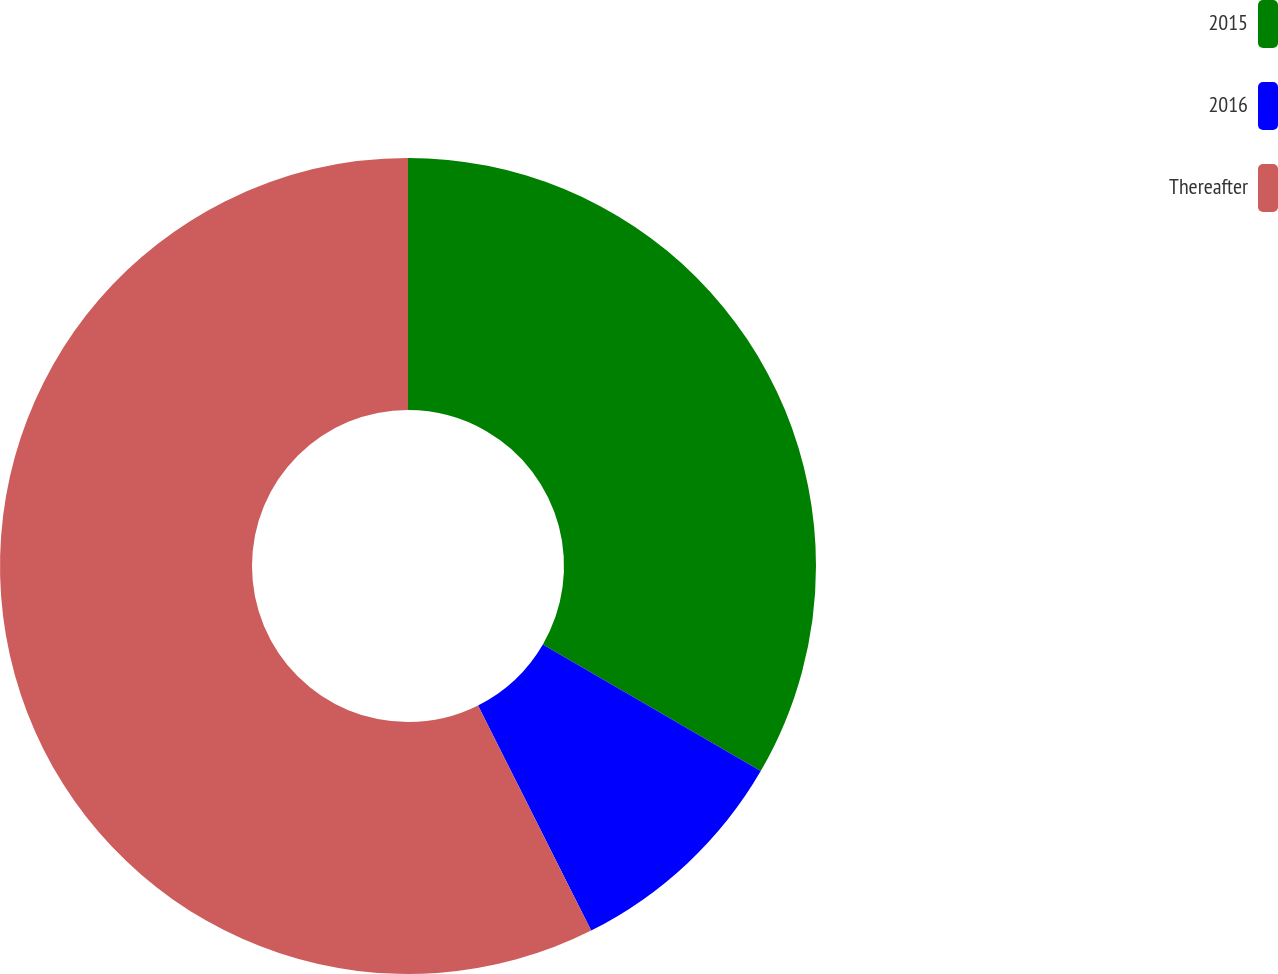Convert chart. <chart><loc_0><loc_0><loc_500><loc_500><pie_chart><fcel>2015<fcel>2016<fcel>Thereafter<nl><fcel>33.38%<fcel>9.21%<fcel>57.41%<nl></chart> 